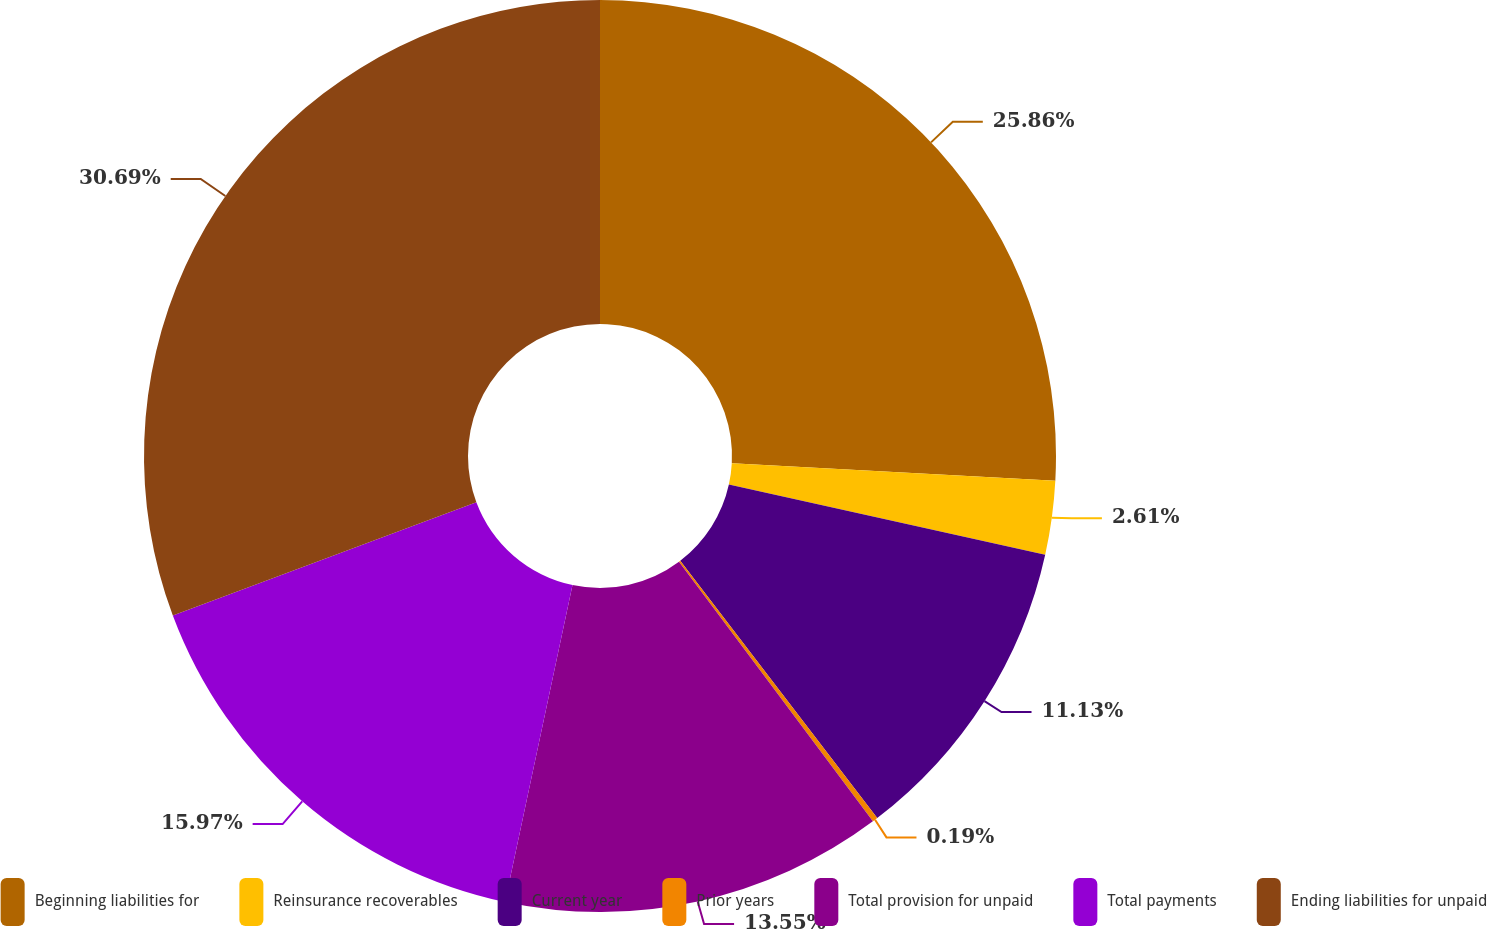Convert chart to OTSL. <chart><loc_0><loc_0><loc_500><loc_500><pie_chart><fcel>Beginning liabilities for<fcel>Reinsurance recoverables<fcel>Current year<fcel>Prior years<fcel>Total provision for unpaid<fcel>Total payments<fcel>Ending liabilities for unpaid<nl><fcel>25.86%<fcel>2.61%<fcel>11.13%<fcel>0.19%<fcel>13.55%<fcel>15.97%<fcel>30.69%<nl></chart> 